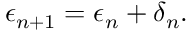<formula> <loc_0><loc_0><loc_500><loc_500>\epsilon _ { n + 1 } = \epsilon _ { n } + \delta _ { n } .</formula> 